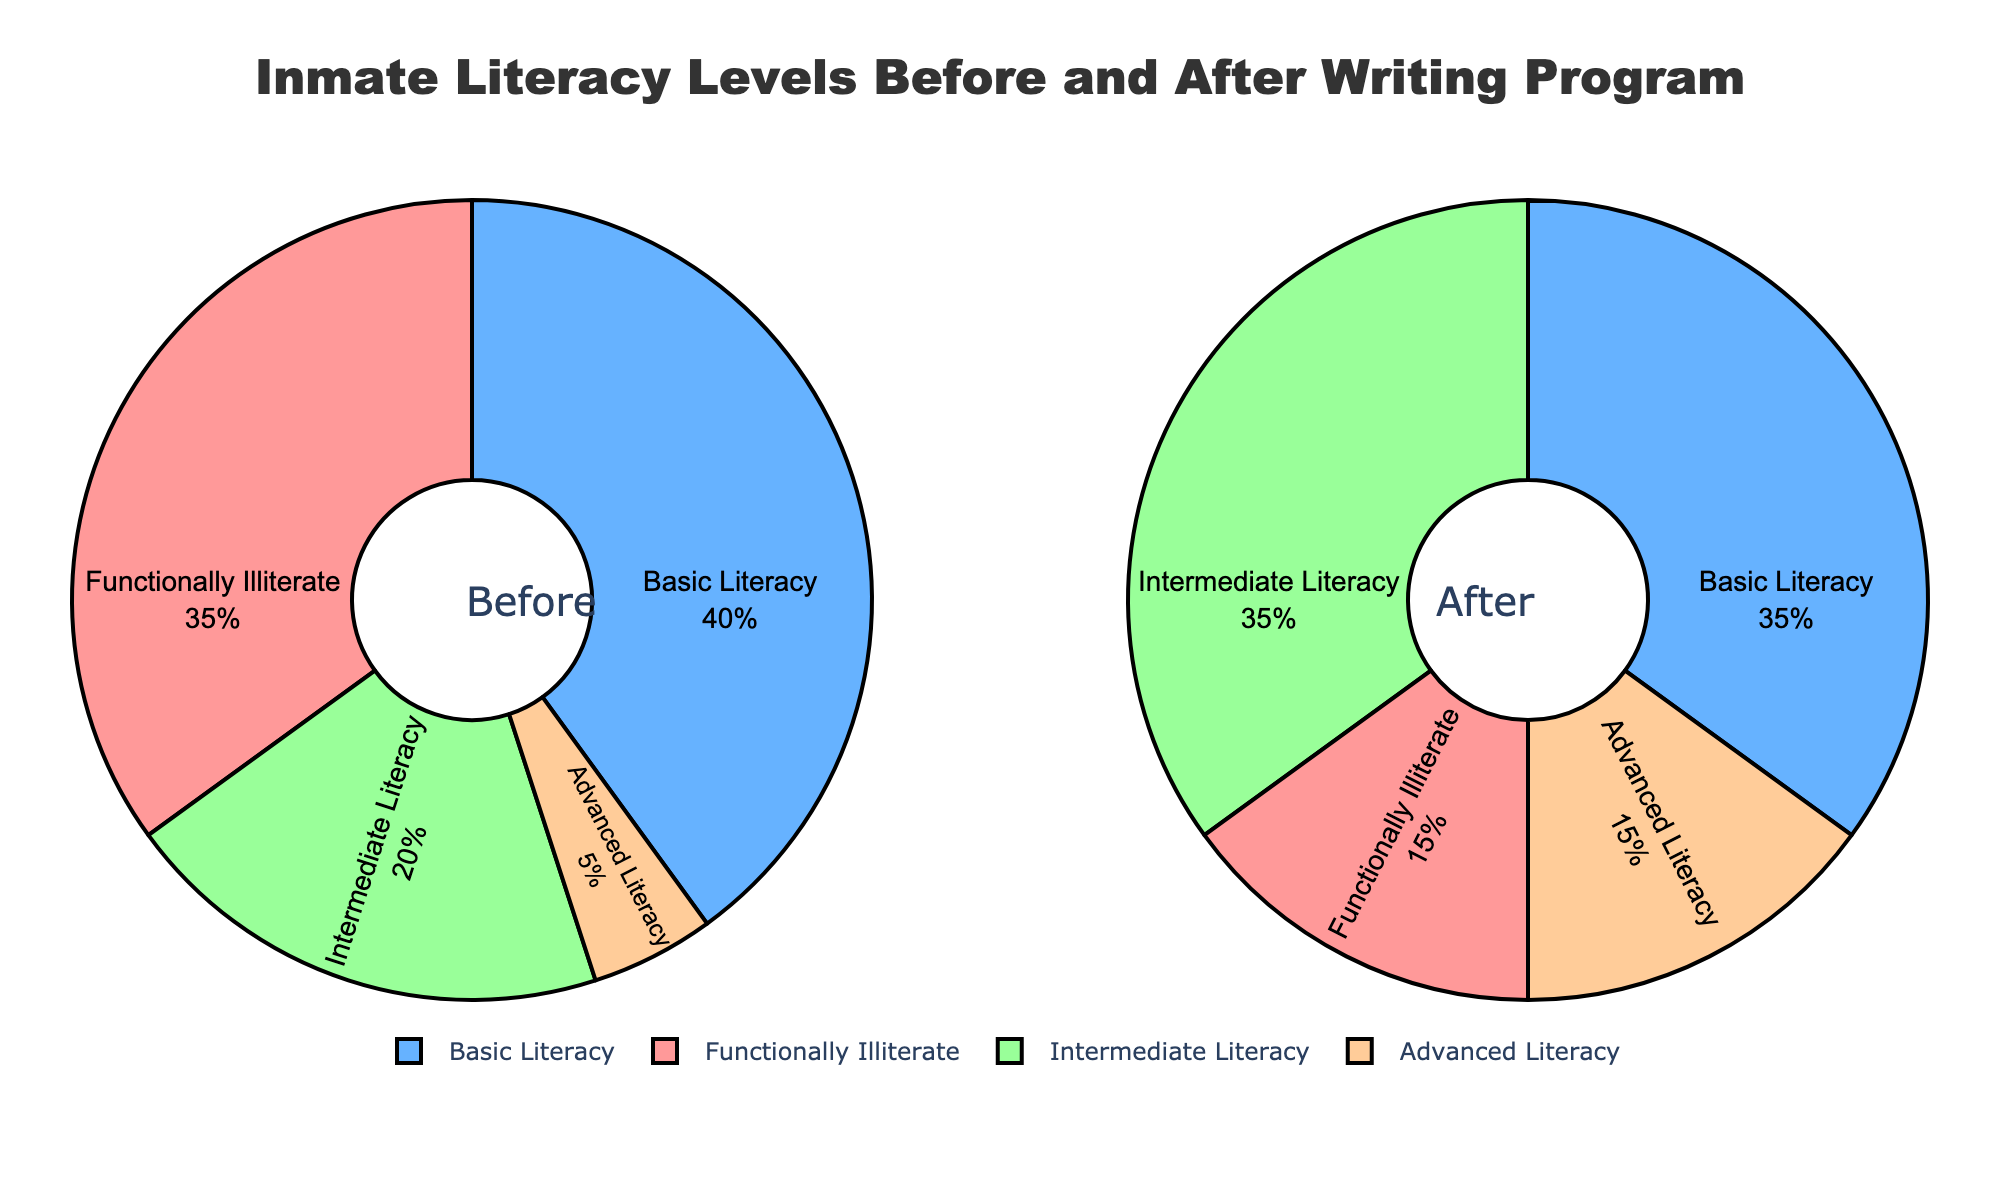What proportion of inmates were functionally illiterate before the program? Look at the slice labeled "Functionally Illiterate" in the "Before" pie chart. It represents 35%.
Answer: 35% What is the difference in the proportion of functionally illiterate inmates before and after the program? Subtract the proportion of functionally illiterate inmates after the program from the proportion before the program: 35% - 15% = 20%.
Answer: 20% Which literacy level category saw the most significant increase in proportion after the program? Compare the increase in proportion for each literacy level. "Intermediate Literacy" increased from 20% to 35%, giving an increase of 15%, which is the highest.
Answer: Intermediate Literacy What is the combined proportion of inmates with basic and intermediate literacy after the program? Add the proportions of "Basic Literacy" and "Intermediate Literacy" after the program: 35% + 35% = 70%.
Answer: 70% By how much did the proportion of inmates with advanced literacy increase after the program? Subtract the proportion of advanced literacy before the program from the proportion after the program: 15% - 5% = 10%.
Answer: 10% Which category has the smallest proportion after the program? Compare the proportions of all literacy levels after the program. "Functionally Illiterate" has the smallest proportion at 15%.
Answer: Functionally Illiterate How did the proportion of inmates with basic literacy change after participating in the program? Subtract the proportion of basic literacy before the program from the proportion after the program: 35% - 40% = -5%. This indicates a decrease.
Answer: Decreased by 5% What was the total proportion of inmates with intermediate or advanced literacy before the program? Add the proportion of inmates with intermediate literacy and advanced literacy before the program: 20% + 5% = 25%.
Answer: 25% How does the proportion of functionally illiterate inmates compare to those with advanced literacy after the program? Compare the proportions of functionally illiterate and advanced literacy after the program. Both are equal at 15%.
Answer: Equal 